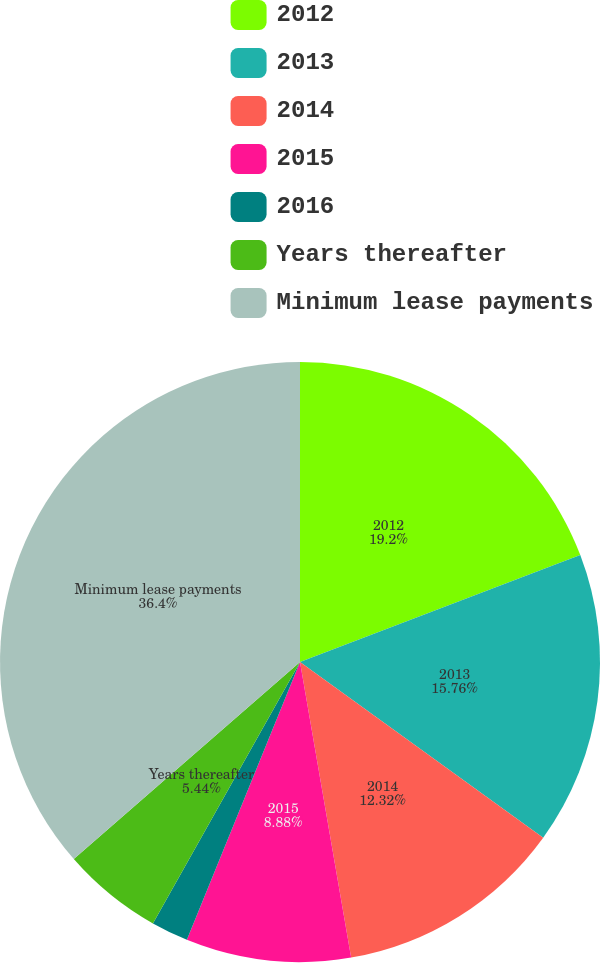<chart> <loc_0><loc_0><loc_500><loc_500><pie_chart><fcel>2012<fcel>2013<fcel>2014<fcel>2015<fcel>2016<fcel>Years thereafter<fcel>Minimum lease payments<nl><fcel>19.2%<fcel>15.76%<fcel>12.32%<fcel>8.88%<fcel>2.0%<fcel>5.44%<fcel>36.41%<nl></chart> 